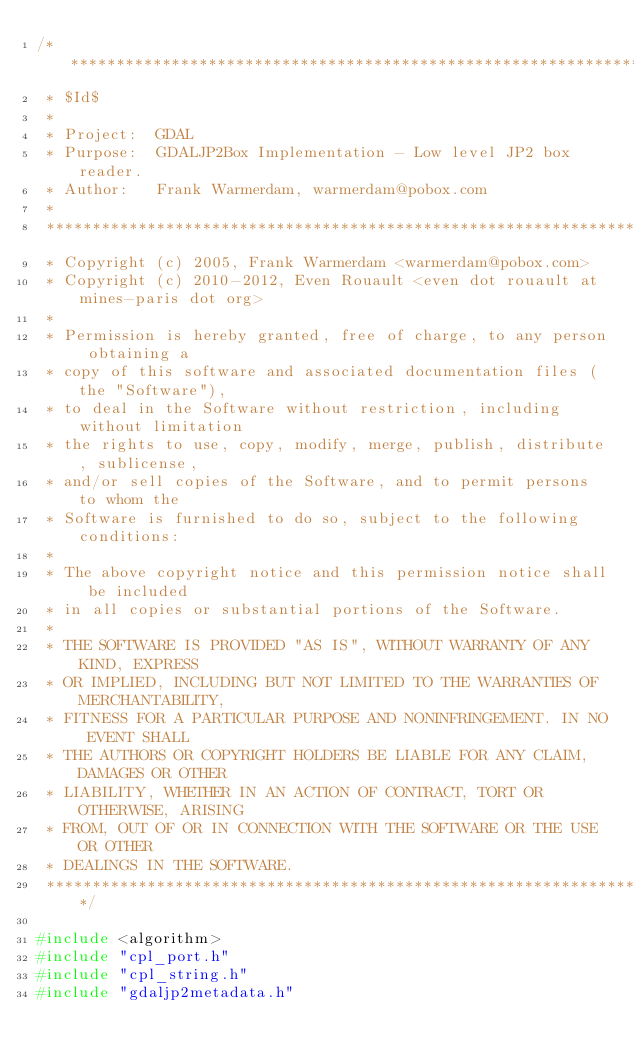<code> <loc_0><loc_0><loc_500><loc_500><_C++_>/******************************************************************************
 * $Id$
 *
 * Project:  GDAL
 * Purpose:  GDALJP2Box Implementation - Low level JP2 box reader.
 * Author:   Frank Warmerdam, warmerdam@pobox.com
 *
 ******************************************************************************
 * Copyright (c) 2005, Frank Warmerdam <warmerdam@pobox.com>
 * Copyright (c) 2010-2012, Even Rouault <even dot rouault at mines-paris dot org>
 *
 * Permission is hereby granted, free of charge, to any person obtaining a
 * copy of this software and associated documentation files (the "Software"),
 * to deal in the Software without restriction, including without limitation
 * the rights to use, copy, modify, merge, publish, distribute, sublicense,
 * and/or sell copies of the Software, and to permit persons to whom the
 * Software is furnished to do so, subject to the following conditions:
 *
 * The above copyright notice and this permission notice shall be included
 * in all copies or substantial portions of the Software.
 *
 * THE SOFTWARE IS PROVIDED "AS IS", WITHOUT WARRANTY OF ANY KIND, EXPRESS
 * OR IMPLIED, INCLUDING BUT NOT LIMITED TO THE WARRANTIES OF MERCHANTABILITY,
 * FITNESS FOR A PARTICULAR PURPOSE AND NONINFRINGEMENT. IN NO EVENT SHALL
 * THE AUTHORS OR COPYRIGHT HOLDERS BE LIABLE FOR ANY CLAIM, DAMAGES OR OTHER
 * LIABILITY, WHETHER IN AN ACTION OF CONTRACT, TORT OR OTHERWISE, ARISING
 * FROM, OUT OF OR IN CONNECTION WITH THE SOFTWARE OR THE USE OR OTHER
 * DEALINGS IN THE SOFTWARE.
 ****************************************************************************/

#include <algorithm>
#include "cpl_port.h"
#include "cpl_string.h"
#include "gdaljp2metadata.h"
</code> 